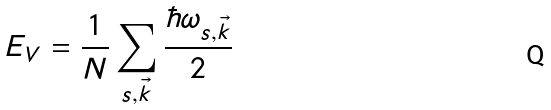<formula> <loc_0><loc_0><loc_500><loc_500>E _ { V } = \frac { 1 } { N } \sum _ { s , \vec { k } } \frac { \hbar { \omega } _ { s , \vec { k } } } { 2 }</formula> 